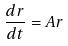Convert formula to latex. <formula><loc_0><loc_0><loc_500><loc_500>\frac { d r } { d t } = A r</formula> 